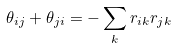<formula> <loc_0><loc_0><loc_500><loc_500>\theta _ { i j } + \theta _ { j i } = - \sum _ { k } r _ { i k } r _ { j k }</formula> 